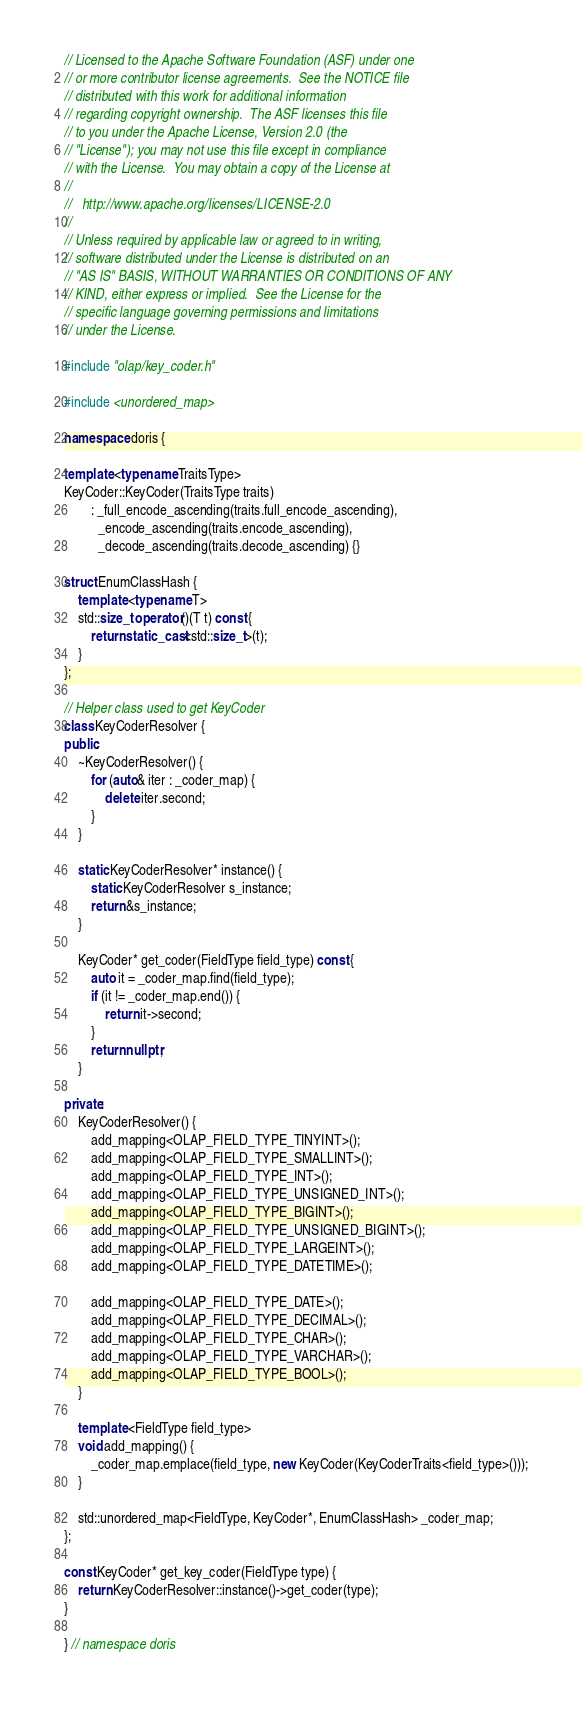Convert code to text. <code><loc_0><loc_0><loc_500><loc_500><_C++_>// Licensed to the Apache Software Foundation (ASF) under one
// or more contributor license agreements.  See the NOTICE file
// distributed with this work for additional information
// regarding copyright ownership.  The ASF licenses this file
// to you under the Apache License, Version 2.0 (the
// "License"); you may not use this file except in compliance
// with the License.  You may obtain a copy of the License at
//
//   http://www.apache.org/licenses/LICENSE-2.0
//
// Unless required by applicable law or agreed to in writing,
// software distributed under the License is distributed on an
// "AS IS" BASIS, WITHOUT WARRANTIES OR CONDITIONS OF ANY
// KIND, either express or implied.  See the License for the
// specific language governing permissions and limitations
// under the License.

#include "olap/key_coder.h"

#include <unordered_map>

namespace doris {

template <typename TraitsType>
KeyCoder::KeyCoder(TraitsType traits)
        : _full_encode_ascending(traits.full_encode_ascending),
          _encode_ascending(traits.encode_ascending),
          _decode_ascending(traits.decode_ascending) {}

struct EnumClassHash {
    template <typename T>
    std::size_t operator()(T t) const {
        return static_cast<std::size_t>(t);
    }
};

// Helper class used to get KeyCoder
class KeyCoderResolver {
public:
    ~KeyCoderResolver() {
        for (auto& iter : _coder_map) {
            delete iter.second;
        }
    }

    static KeyCoderResolver* instance() {
        static KeyCoderResolver s_instance;
        return &s_instance;
    }

    KeyCoder* get_coder(FieldType field_type) const {
        auto it = _coder_map.find(field_type);
        if (it != _coder_map.end()) {
            return it->second;
        }
        return nullptr;
    }

private:
    KeyCoderResolver() {
        add_mapping<OLAP_FIELD_TYPE_TINYINT>();
        add_mapping<OLAP_FIELD_TYPE_SMALLINT>();
        add_mapping<OLAP_FIELD_TYPE_INT>();
        add_mapping<OLAP_FIELD_TYPE_UNSIGNED_INT>();
        add_mapping<OLAP_FIELD_TYPE_BIGINT>();
        add_mapping<OLAP_FIELD_TYPE_UNSIGNED_BIGINT>();
        add_mapping<OLAP_FIELD_TYPE_LARGEINT>();
        add_mapping<OLAP_FIELD_TYPE_DATETIME>();

        add_mapping<OLAP_FIELD_TYPE_DATE>();
        add_mapping<OLAP_FIELD_TYPE_DECIMAL>();
        add_mapping<OLAP_FIELD_TYPE_CHAR>();
        add_mapping<OLAP_FIELD_TYPE_VARCHAR>();
        add_mapping<OLAP_FIELD_TYPE_BOOL>();
    }

    template <FieldType field_type>
    void add_mapping() {
        _coder_map.emplace(field_type, new KeyCoder(KeyCoderTraits<field_type>()));
    }

    std::unordered_map<FieldType, KeyCoder*, EnumClassHash> _coder_map;
};

const KeyCoder* get_key_coder(FieldType type) {
    return KeyCoderResolver::instance()->get_coder(type);
}

} // namespace doris
</code> 